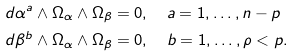Convert formula to latex. <formula><loc_0><loc_0><loc_500><loc_500>& d \alpha ^ { a } \wedge \Omega _ { \alpha } \wedge \Omega _ { \beta } = 0 , \quad a = 1 , \dots , n - p \\ & d \beta ^ { b } \wedge \Omega _ { \alpha } \wedge \Omega _ { \beta } = 0 , \quad b = 1 , \dots , \rho < p .</formula> 